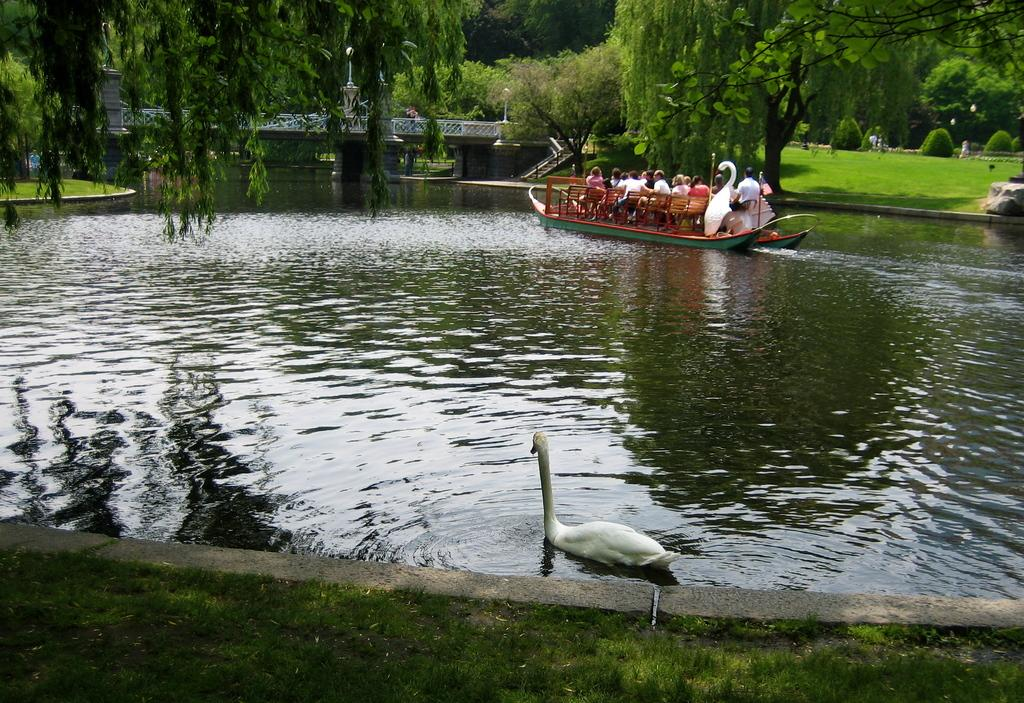What are the people in the image doing? The people in the image are sitting on a boat. What can be seen in the water near the boat? There is a duck in the water in the image. What type of vegetation is present in the image? There are trees and plants in the image. What is the rock used for in the image? The rock is a natural feature in the image and does not have a specific use. What structure can be seen in the image? There is a bridge in the image. What type of pump is visible in the image? There is no pump present in the image. What kind of drum can be seen being played by the people on the boat? There is no drum visible in the image; the people are simply sitting on the boat. 